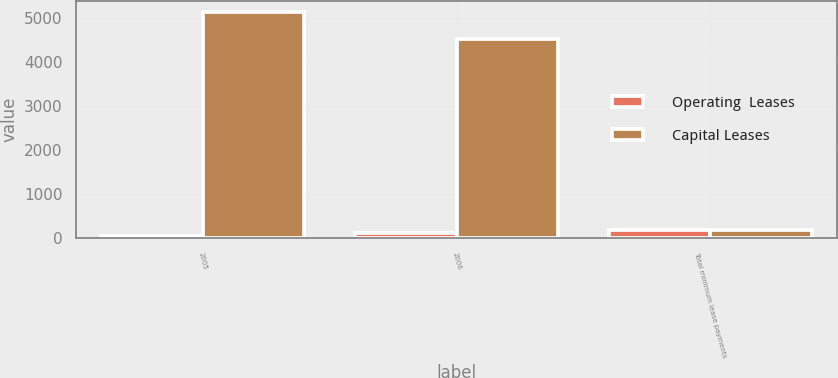Convert chart. <chart><loc_0><loc_0><loc_500><loc_500><stacked_bar_chart><ecel><fcel>2005<fcel>2006<fcel>Total minimum lease payments<nl><fcel>Operating  Leases<fcel>62<fcel>121<fcel>183<nl><fcel>Capital Leases<fcel>5116<fcel>4512<fcel>183<nl></chart> 